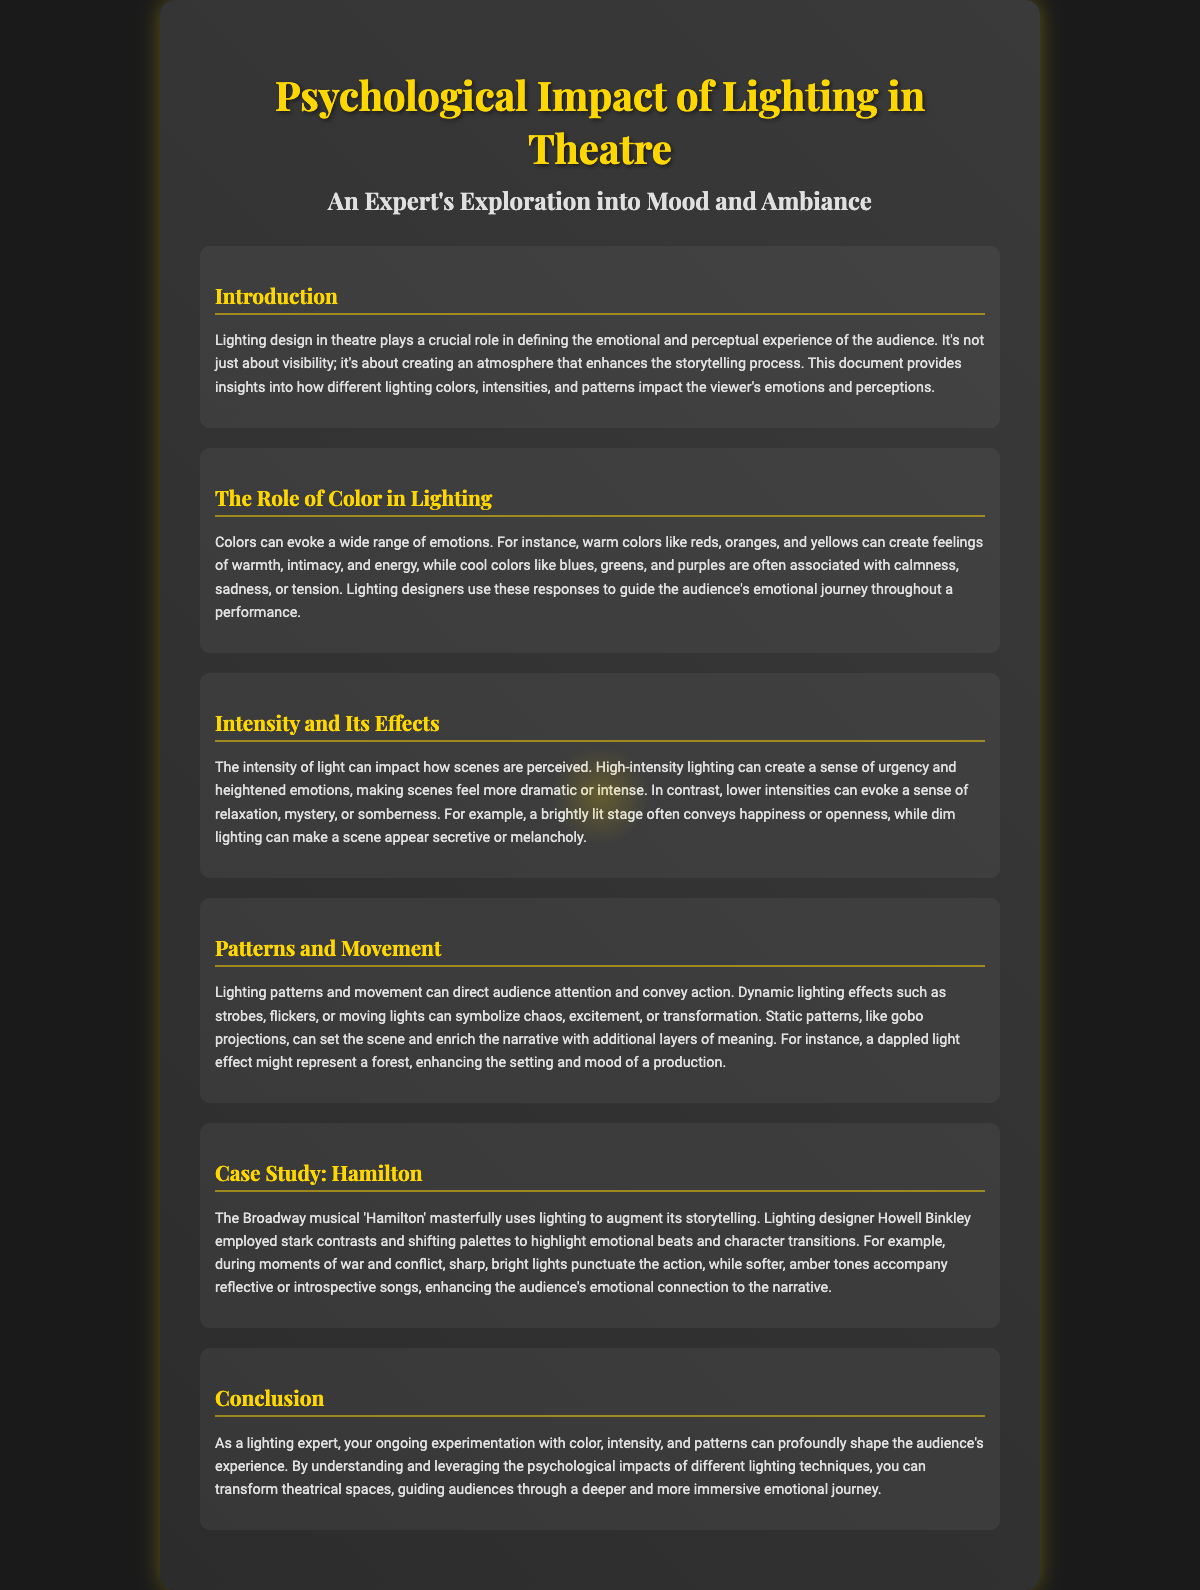what is the title of the document? The title is prominently displayed at the top of the document, which is "Psychological Impact of Lighting in Theatre."
Answer: Psychological Impact of Lighting in Theatre who is the lighting designer mentioned in the case study? The document refers to Howell Binkley as the lighting designer for the case study of "Hamilton."
Answer: Howell Binkley what does warm lighting create feelings of? The document states that warm colors can create feelings of warmth, intimacy, and energy.
Answer: warmth, intimacy, and energy what emotional tone does low-intensity lighting convey? The text explains that lower intensities can evoke a sense of relaxation, mystery, or somberness.
Answer: relaxation, mystery, or somberness which colors are associated with calmness and tension? The section on color states that cool colors like blues, greens, and purples are often associated with calmness and tension.
Answer: blues, greens, and purples how does dynamic lighting effects symbolize excitement? The document mentions that dynamic lighting effects such as strobes or flickers can symbolize chaos, excitement, or transformation.
Answer: chaos, excitement, or transformation what musical is studied as a case in the document? The document specifically analyzes the Broadway musical "Hamilton."
Answer: Hamilton what effect does dappled light represent in the context of the document? The section about patterns explains that dappled light effects might represent a forest, enhancing the setting.
Answer: a forest 